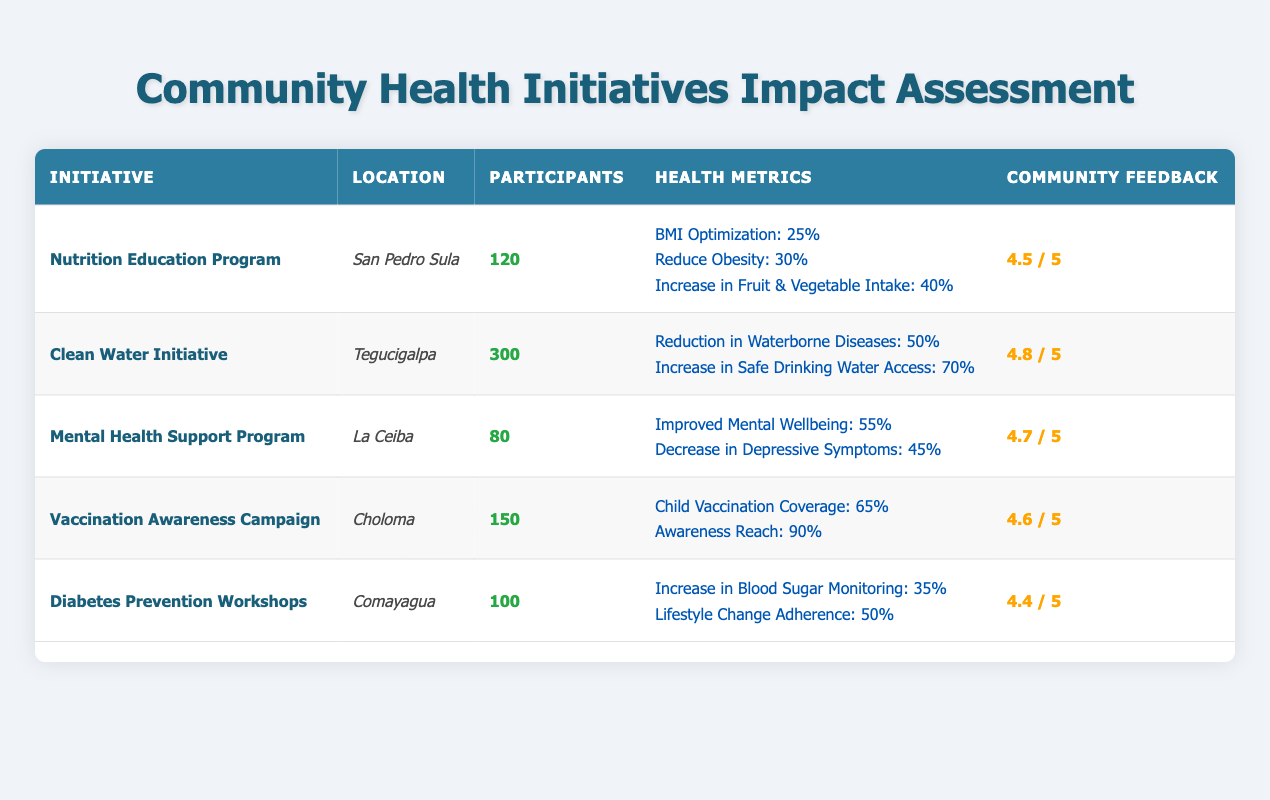What was the community feedback rating for the Clean Water Initiative? According to the table, the community feedback rating for the Clean Water Initiative is 4.8 out of 5.
Answer: 4.8 How many participants were involved in the Mental Health Support Program? The table indicates that there were 80 participants in the Mental Health Support Program.
Answer: 80 Which initiative had the highest percentage of health improvement related to waterborne diseases? The Clean Water Initiative had a 50% reduction in waterborne diseases, which is the highest among the initiatives listed.
Answer: Clean Water Initiative What is the average community feedback rating for the Diabetes Prevention Workshops and the Nutrition Education Program? The ratings for the Diabetes Prevention Workshops (4.4) and the Nutrition Education Program (4.5) are summed to give a total of 8.9. Dividing this by 2 gives an average of 4.45.
Answer: 4.45 Did the Vaccination Awareness Campaign improve child vaccination coverage? Yes, the table shows that the Vaccination Awareness Campaign resulted in a 65% child vaccination coverage.
Answer: Yes What is the difference in community feedback between the Clean Water Initiative and the Diabetes Prevention Workshops? The feedback for the Clean Water Initiative is 4.8, and for the Diabetes Prevention Workshops, it's 4.4. The difference is 4.8 - 4.4 = 0.4.
Answer: 0.4 Which initiative reported the highest percentage of improvement in mental wellbeing? The Mental Health Support Program reported a 55% improvement in mental wellbeing, which is the highest among all initiatives listed.
Answer: Mental Health Support Program How many total participants were involved across all initiatives listed? By adding the participants from each initiative: 120 (Nutrition Education) + 300 (Clean Water) + 80 (Mental Health) + 150 (Vaccination Awareness) + 100 (Diabetes Prevention) = 1050 participants in total.
Answer: 1050 